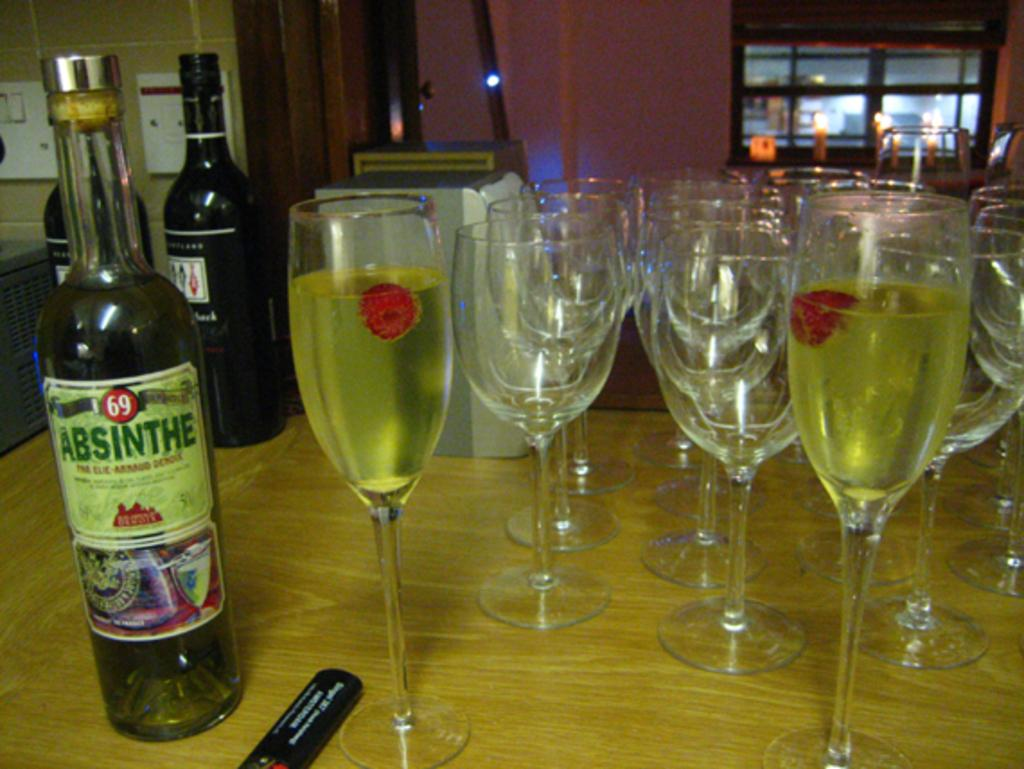How many wine bottles are visible in the image? There are three wine bottles in the image. What else is present on the table with the wine bottles? There are wine glasses in the image. Where are the wine bottles and glasses located? The wine bottles and glasses are on a table. What is the educational background of the person who arranged the wine bottles and glasses in the image? There is no information about the person who arranged the wine bottles and glasses in the image, so their educational background cannot be determined. 